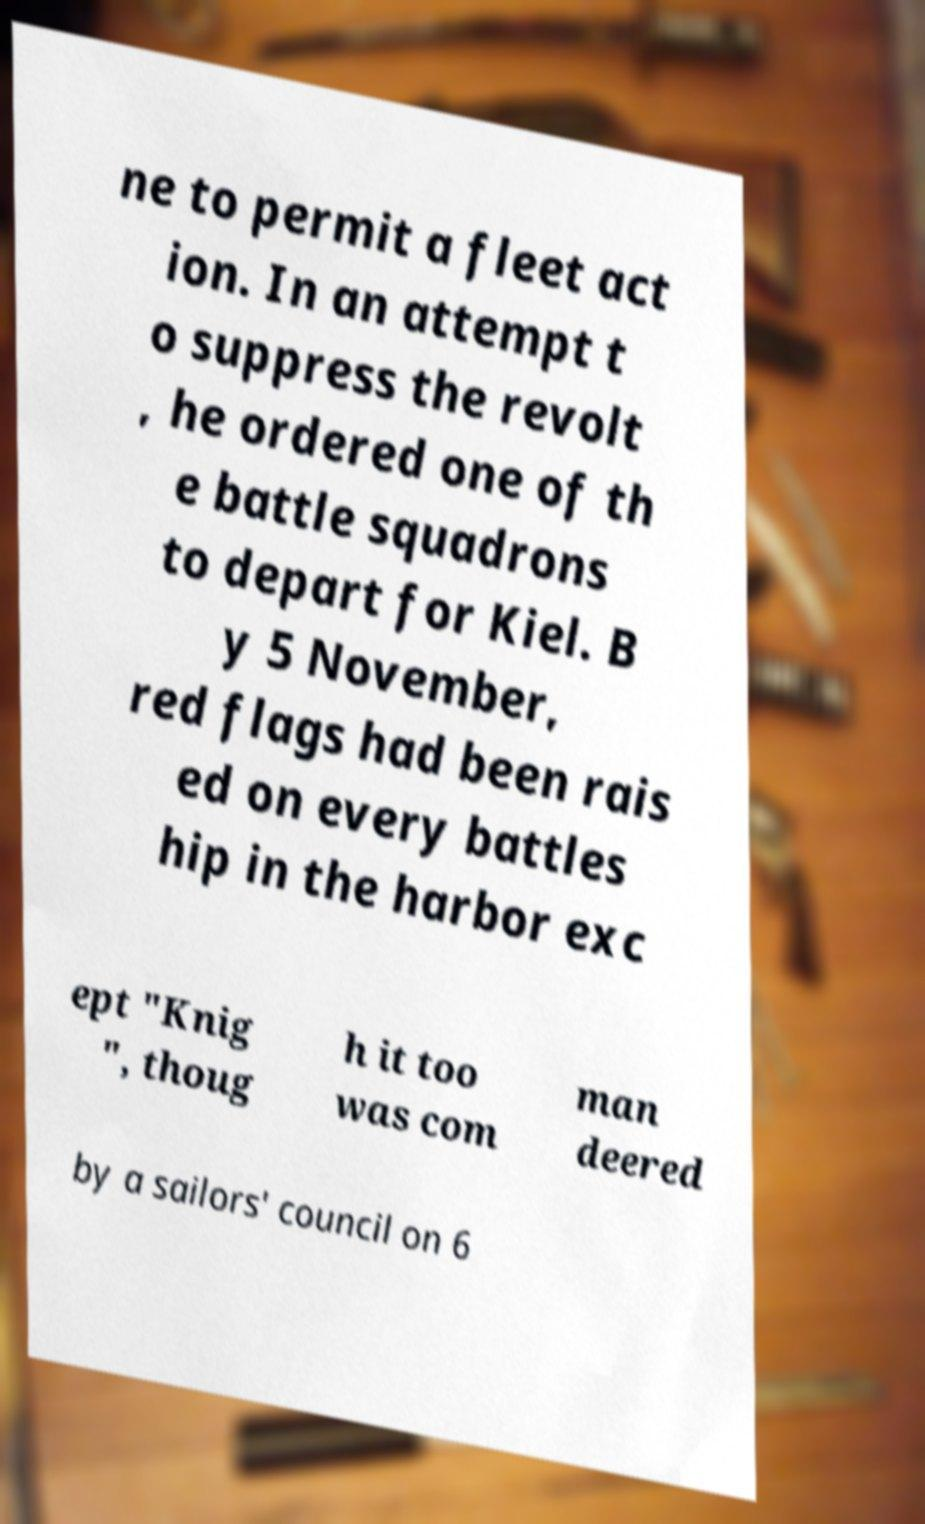Please identify and transcribe the text found in this image. ne to permit a fleet act ion. In an attempt t o suppress the revolt , he ordered one of th e battle squadrons to depart for Kiel. B y 5 November, red flags had been rais ed on every battles hip in the harbor exc ept "Knig ", thoug h it too was com man deered by a sailors' council on 6 